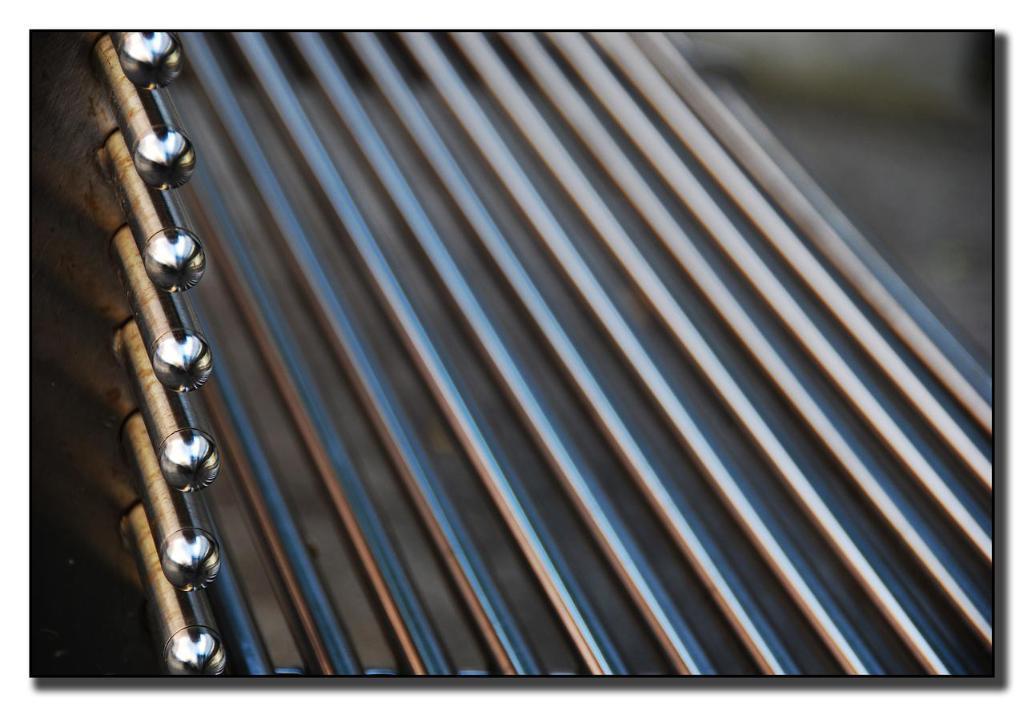In one or two sentences, can you explain what this image depicts? In this picture we can see a metal sheet and metal rods. 